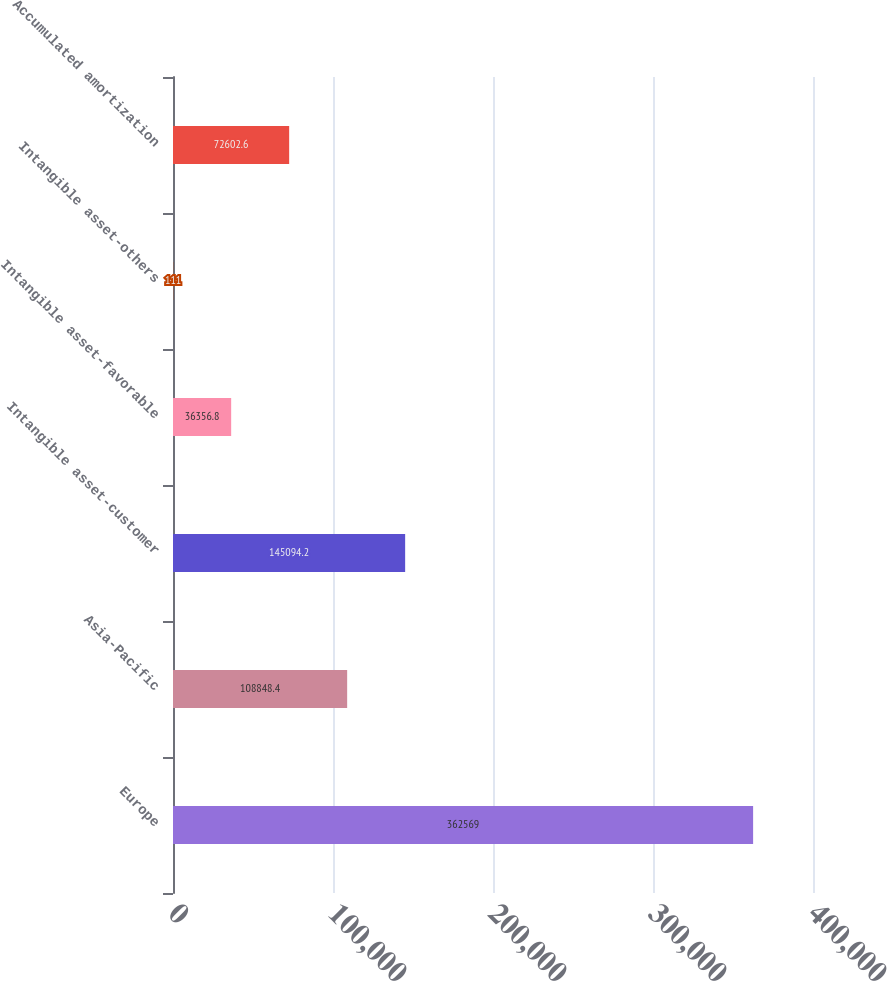<chart> <loc_0><loc_0><loc_500><loc_500><bar_chart><fcel>Europe<fcel>Asia-Pacific<fcel>Intangible asset-customer<fcel>Intangible asset-favorable<fcel>Intangible asset-others<fcel>Accumulated amortization<nl><fcel>362569<fcel>108848<fcel>145094<fcel>36356.8<fcel>111<fcel>72602.6<nl></chart> 